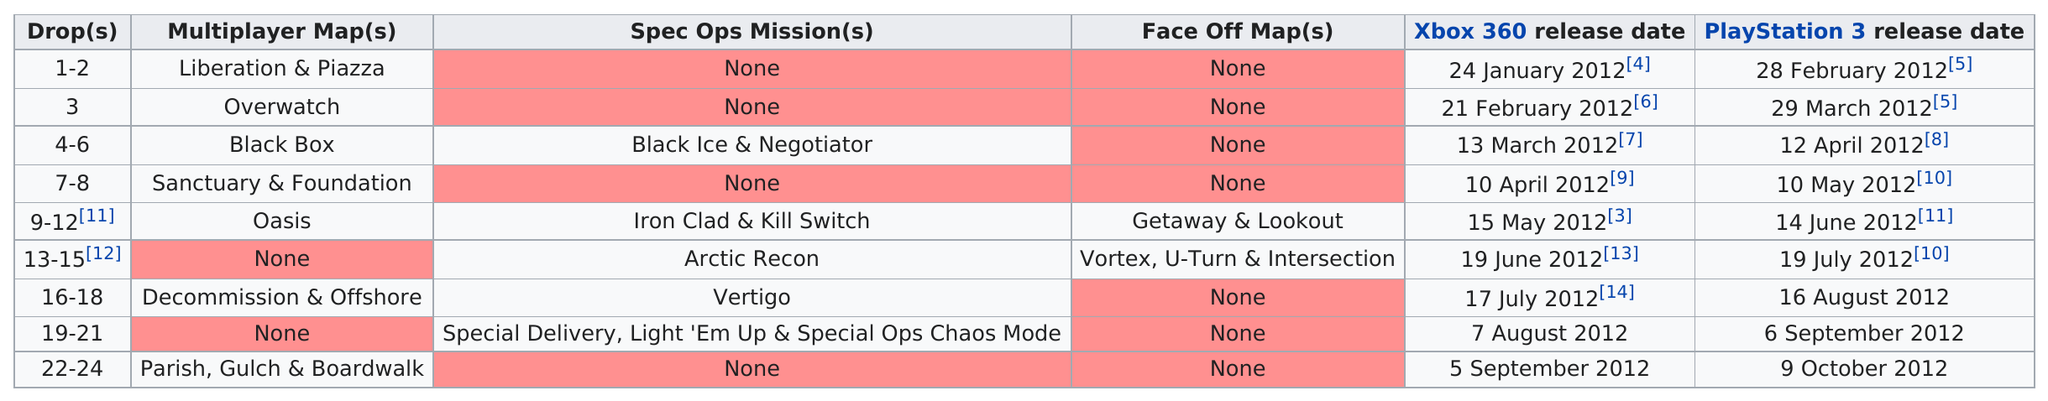List a handful of essential elements in this visual. The first release date of the PlayStation 3 was on February 28, 2012. During the period of January 2012 to October 2012, the number of multiplayer maps was reduced from 7 to... The last release date for the Xbox 360 was on September 5, 2012. Please provide the number of face-off maps available, including the current count of 5. The release date gap between the Xbox 360 release of Overwatch and the Playstation 3 release was 37 days. 